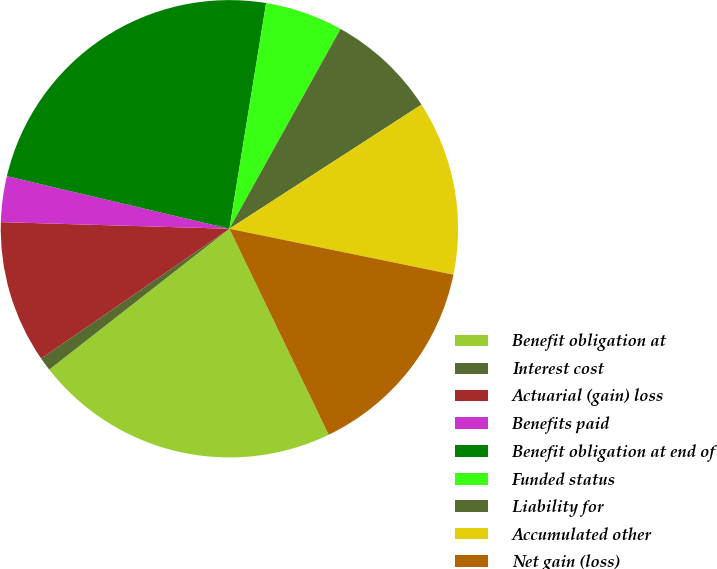Convert chart. <chart><loc_0><loc_0><loc_500><loc_500><pie_chart><fcel>Benefit obligation at<fcel>Interest cost<fcel>Actuarial (gain) loss<fcel>Benefits paid<fcel>Benefit obligation at end of<fcel>Funded status<fcel>Liability for<fcel>Accumulated other<fcel>Net gain (loss)<nl><fcel>21.59%<fcel>0.95%<fcel>10.07%<fcel>3.23%<fcel>23.87%<fcel>5.51%<fcel>7.79%<fcel>12.35%<fcel>14.63%<nl></chart> 